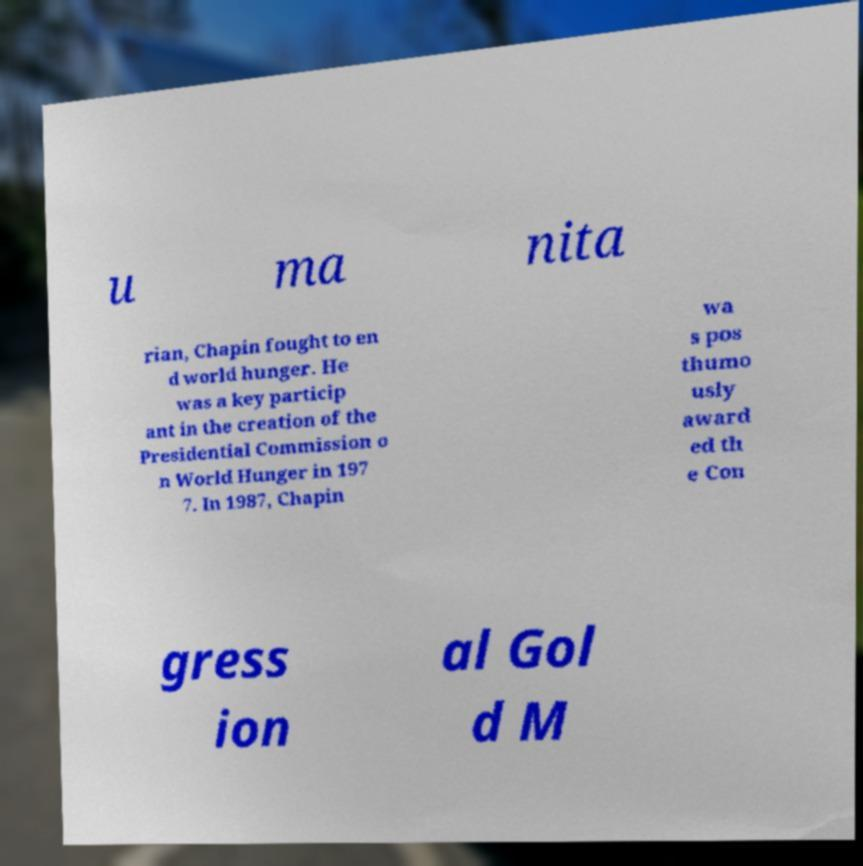There's text embedded in this image that I need extracted. Can you transcribe it verbatim? u ma nita rian, Chapin fought to en d world hunger. He was a key particip ant in the creation of the Presidential Commission o n World Hunger in 197 7. In 1987, Chapin wa s pos thumo usly award ed th e Con gress ion al Gol d M 